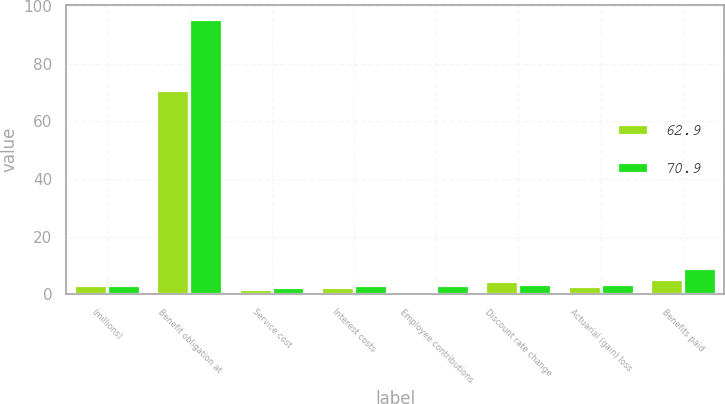Convert chart to OTSL. <chart><loc_0><loc_0><loc_500><loc_500><stacked_bar_chart><ecel><fcel>(millions)<fcel>Benefit obligation at<fcel>Service cost<fcel>Interest costs<fcel>Employee contributions<fcel>Discount rate change<fcel>Actuarial (gain) loss<fcel>Benefits paid<nl><fcel>62.9<fcel>3.4<fcel>70.9<fcel>2<fcel>2.4<fcel>0.4<fcel>4.5<fcel>3<fcel>5.2<nl><fcel>70.9<fcel>3.4<fcel>95.5<fcel>2.6<fcel>3.3<fcel>3.2<fcel>3.7<fcel>3.5<fcel>9.2<nl></chart> 